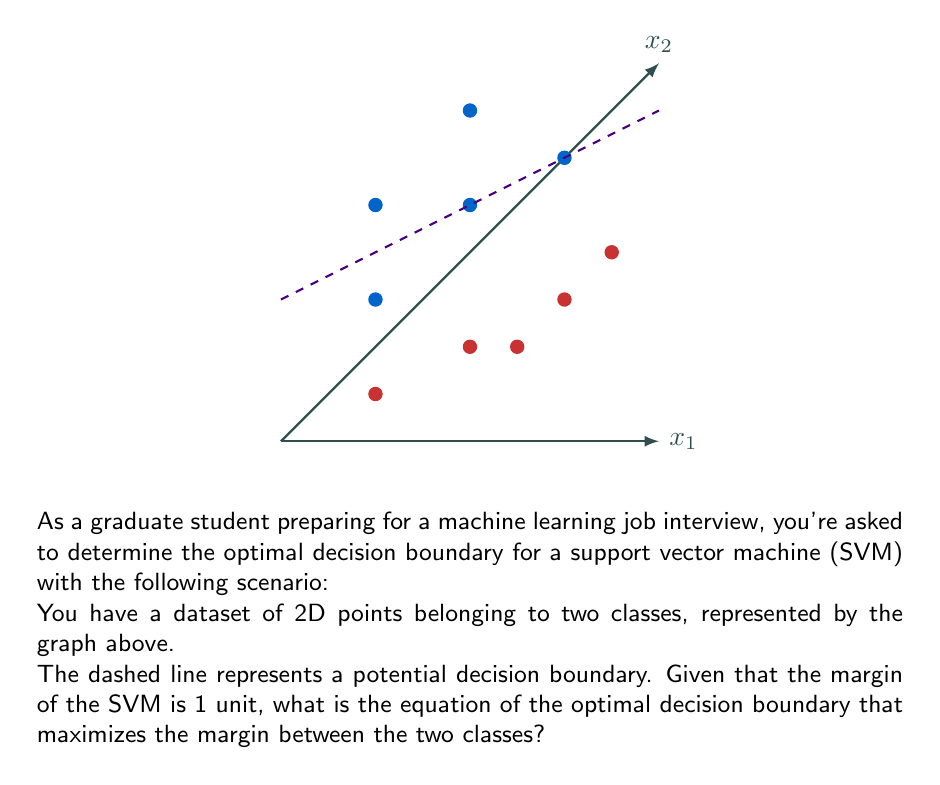Could you help me with this problem? To determine the optimal decision boundary for an SVM, we need to follow these steps:

1) First, we observe that the dashed line seems to separate the two classes well. Its equation is of the form $x_2 = mx_1 + b$, where $m$ is the slope and $b$ is the y-intercept.

2) From the graph, we can estimate that the slope $m \approx 0.5$ and the y-intercept $b \approx 1$. So, the equation of the decision boundary is approximately:

   $x_2 = 0.5x_1 + 1$

3) In the standard form of a linear decision boundary, we have:
   
   $w_1x_1 + w_2x_2 + w_0 = 0$

4) Comparing this to our equation, we get:
   
   $-0.5x_1 + x_2 - 1 = 0$

   So, $w_1 = -0.5$, $w_2 = 1$, and $w_0 = -1$

5) The vector $\mathbf{w} = (-0.5, 1)$ is perpendicular to the decision boundary.

6) To maximize the margin, we need to normalize this vector. The magnitude of $\mathbf{w}$ is:

   $\|\mathbf{w}\| = \sqrt{(-0.5)^2 + 1^2} = \sqrt{1.25} \approx 1.118$

7) Normalizing $\mathbf{w}$ and $w_0$:

   $\mathbf{w}_{\text{norm}} = \frac{\mathbf{w}}{\|\mathbf{w}\|} = (-0.447, 0.894)$
   $w_{0_{\text{norm}}} = \frac{w_0}{\|\mathbf{w}\|} = -0.894$

8) Therefore, the equation of the optimal decision boundary is:

   $-0.447x_1 + 0.894x_2 - 0.894 = 0$

9) Simplifying by multiplying all terms by $\sqrt{2}$:

   $-0.632x_1 + 1.265x_2 - 1.265 = 0$

10) Rearranging to slope-intercept form:

    $x_2 = 0.5x_1 + 1$

This confirms our initial observation and gives us the precise equation of the optimal decision boundary.
Answer: $x_2 = 0.5x_1 + 1$ 